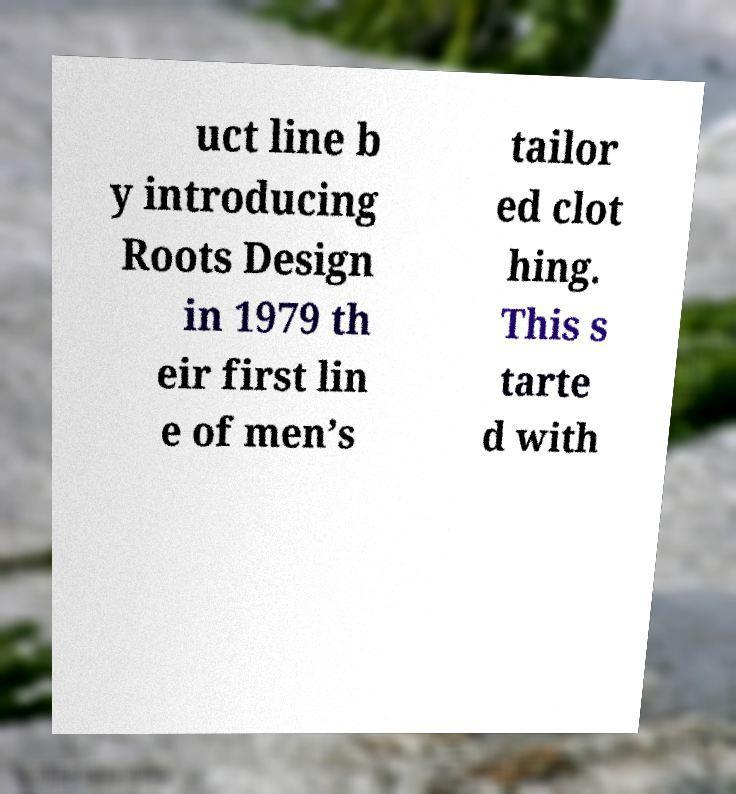I need the written content from this picture converted into text. Can you do that? uct line b y introducing Roots Design in 1979 th eir first lin e of men’s tailor ed clot hing. This s tarte d with 